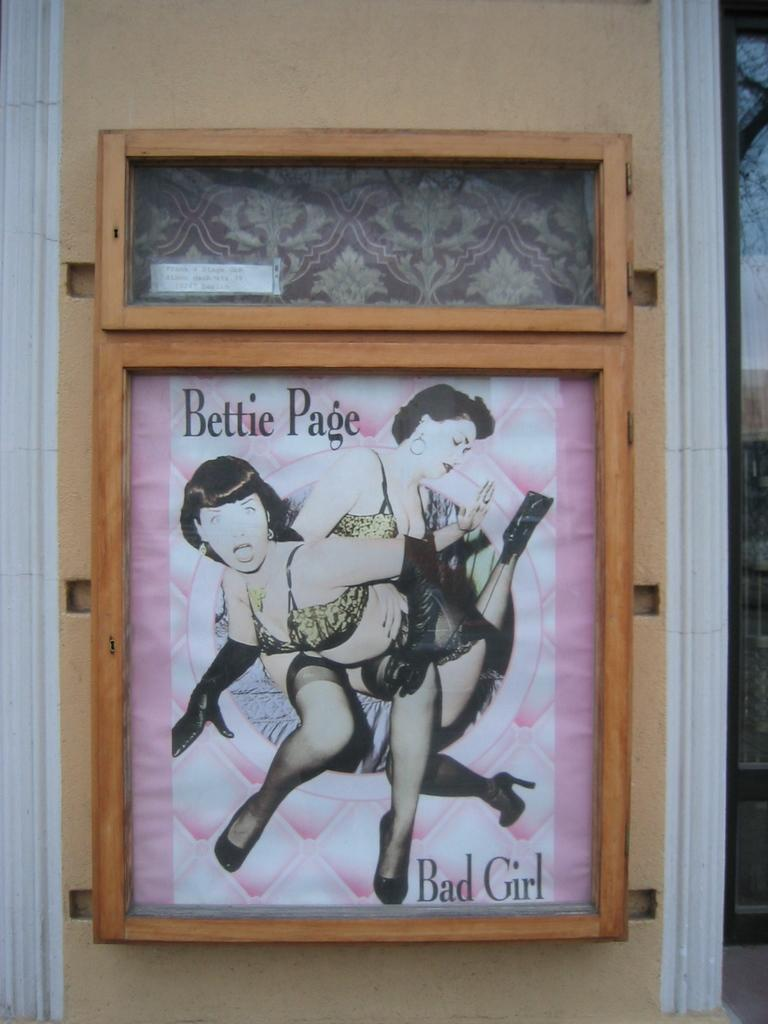<image>
Summarize the visual content of the image. A frame holding a poster that says Bettie Page Bad Girl. 